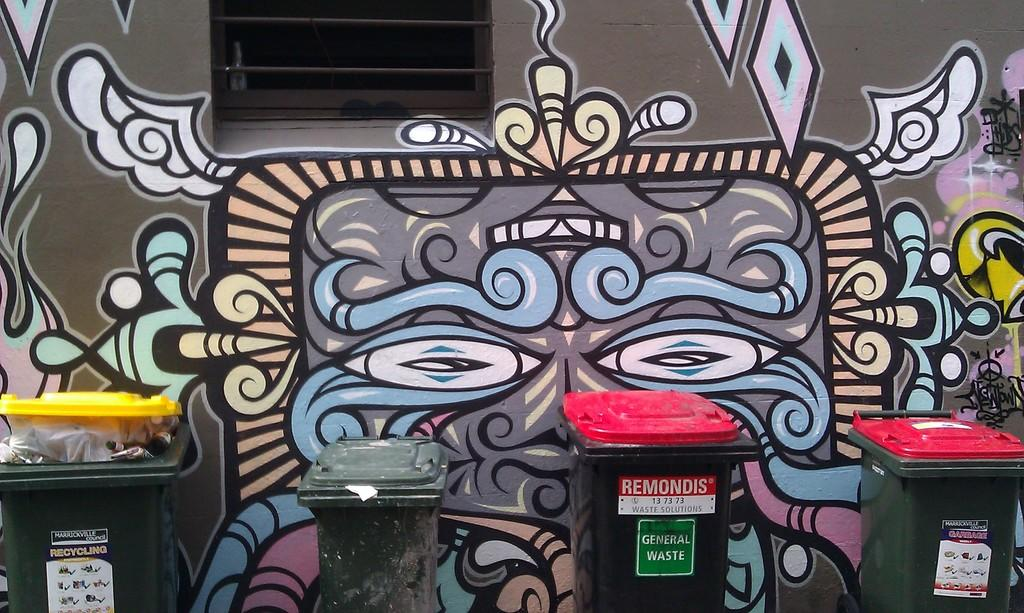Provide a one-sentence caption for the provided image. A door is marked with a green General Waste sign. 